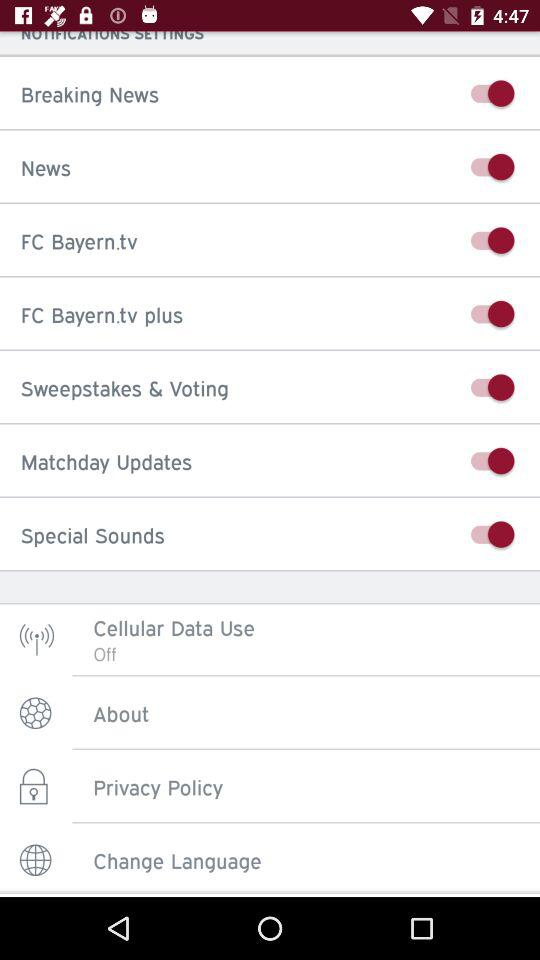What is the status of breaking news? The status is "on". 